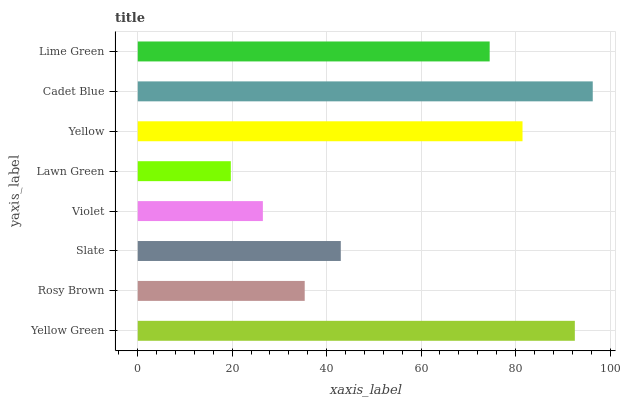Is Lawn Green the minimum?
Answer yes or no. Yes. Is Cadet Blue the maximum?
Answer yes or no. Yes. Is Rosy Brown the minimum?
Answer yes or no. No. Is Rosy Brown the maximum?
Answer yes or no. No. Is Yellow Green greater than Rosy Brown?
Answer yes or no. Yes. Is Rosy Brown less than Yellow Green?
Answer yes or no. Yes. Is Rosy Brown greater than Yellow Green?
Answer yes or no. No. Is Yellow Green less than Rosy Brown?
Answer yes or no. No. Is Lime Green the high median?
Answer yes or no. Yes. Is Slate the low median?
Answer yes or no. Yes. Is Lawn Green the high median?
Answer yes or no. No. Is Lime Green the low median?
Answer yes or no. No. 